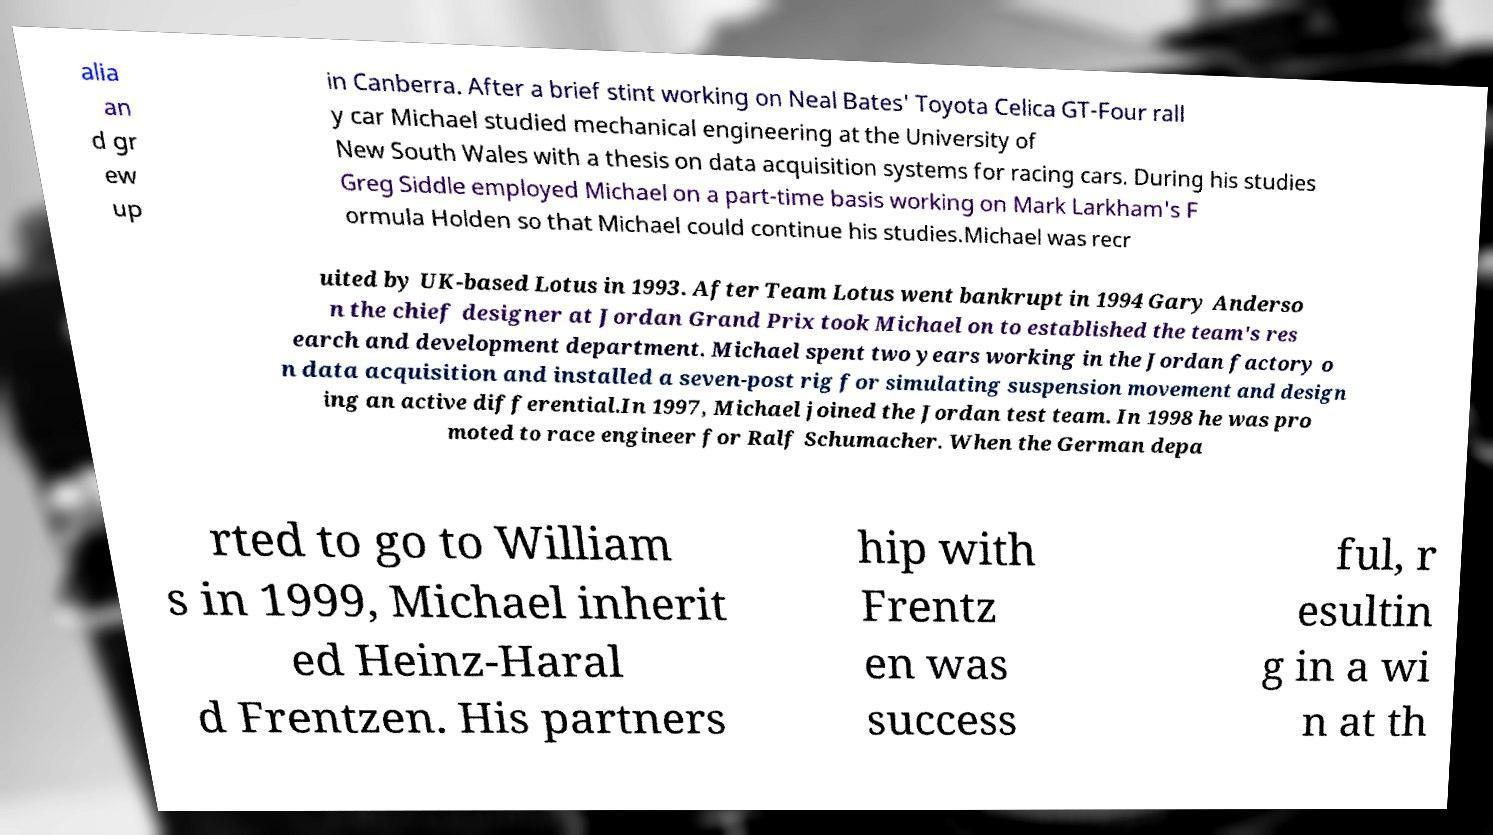There's text embedded in this image that I need extracted. Can you transcribe it verbatim? alia an d gr ew up in Canberra. After a brief stint working on Neal Bates' Toyota Celica GT-Four rall y car Michael studied mechanical engineering at the University of New South Wales with a thesis on data acquisition systems for racing cars. During his studies Greg Siddle employed Michael on a part-time basis working on Mark Larkham's F ormula Holden so that Michael could continue his studies.Michael was recr uited by UK-based Lotus in 1993. After Team Lotus went bankrupt in 1994 Gary Anderso n the chief designer at Jordan Grand Prix took Michael on to established the team's res earch and development department. Michael spent two years working in the Jordan factory o n data acquisition and installed a seven-post rig for simulating suspension movement and design ing an active differential.In 1997, Michael joined the Jordan test team. In 1998 he was pro moted to race engineer for Ralf Schumacher. When the German depa rted to go to William s in 1999, Michael inherit ed Heinz-Haral d Frentzen. His partners hip with Frentz en was success ful, r esultin g in a wi n at th 